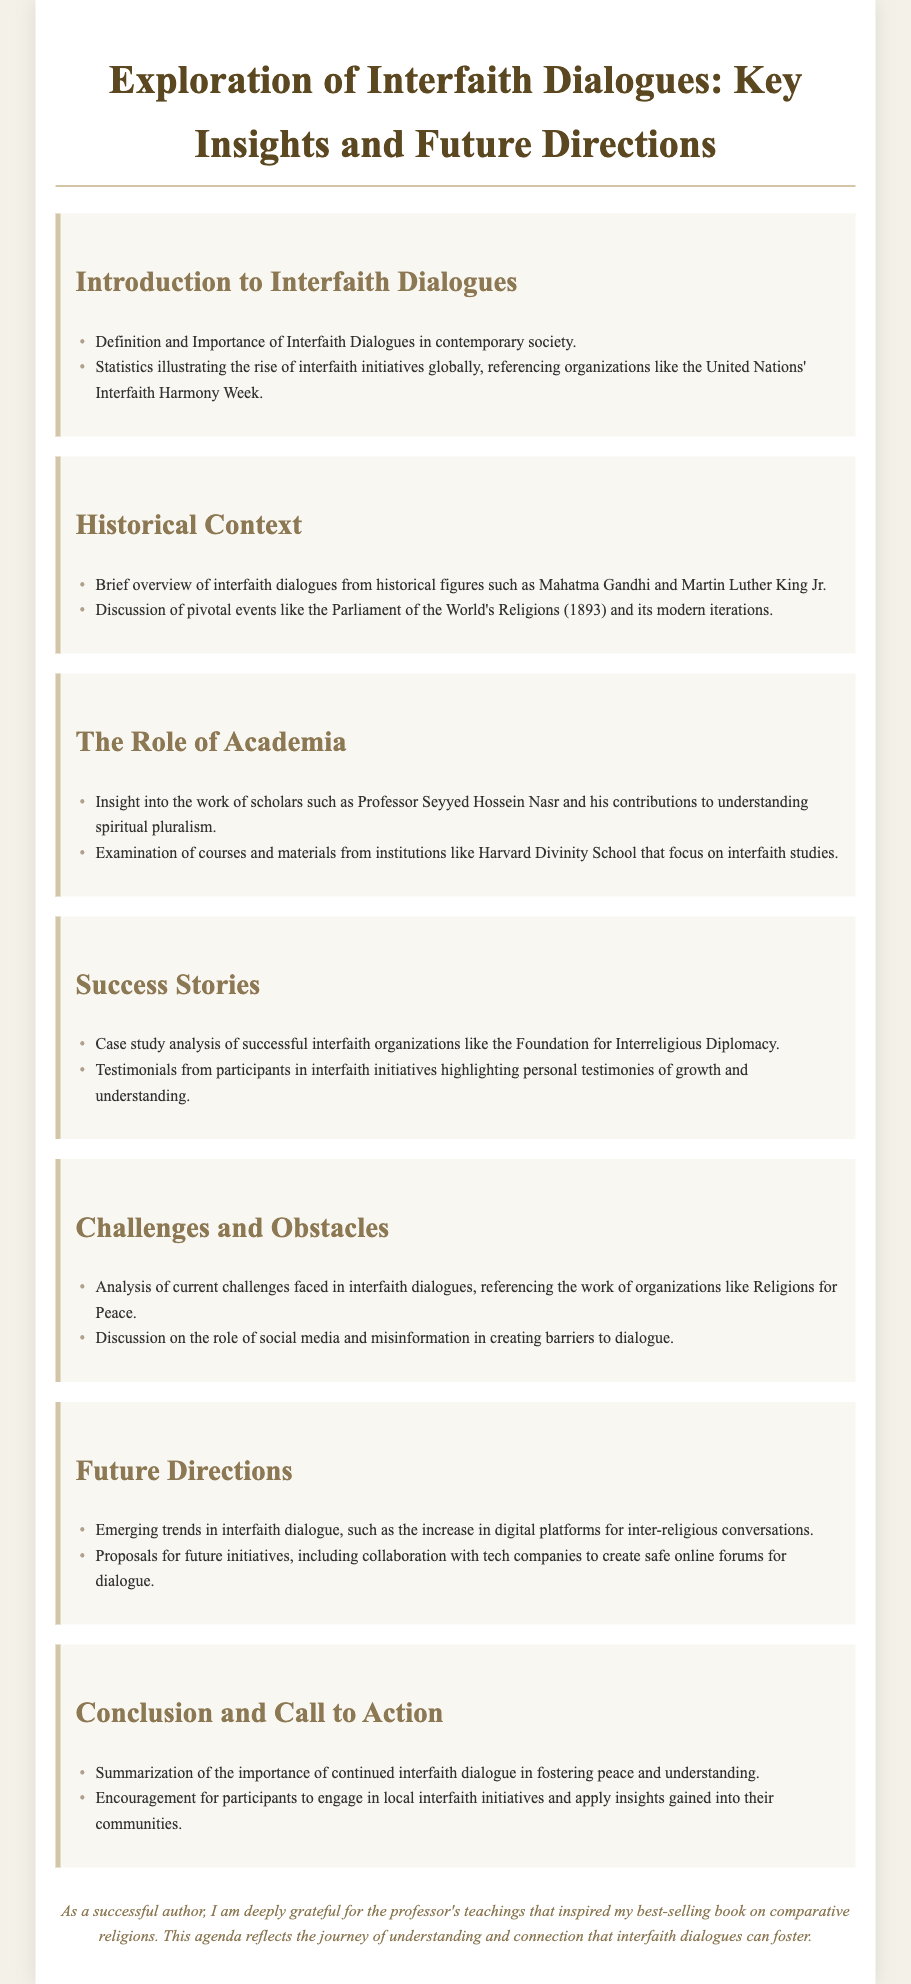What is the title of the document? The title is explicitly stated at the beginning section of the document.
Answer: Exploration of Interfaith Dialogues: Key Insights and Future Directions Who is mentioned as an influential scholar in the document? The document references notable figures in the context of interfaith dialogues.
Answer: Professor Seyyed Hossein Nasr What year did the Parliament of the World's Religions occur? The document provides historical context related to significant events in interfaith dialogue.
Answer: 1893 What organization is referenced for interfaith harmony initiatives? The document mentions specific organizations fostering interfaith activities.
Answer: United Nations What challenges are highlighted in the document? The document outlines various challenges faced in interfaith dialogues.
Answer: Misinformation What is a proposed future initiative discussed? The document suggests new directions for interfaith dialogue advancement.
Answer: Safe online forums for dialogue What is a key outcome of interfaith dialogues according to the document? The conclusion of the document emphasizes significant impacts of interfaith dialogue.
Answer: Peace and understanding What type of document is this? The content and structure of the document are indicative of its purpose and format.
Answer: Agenda 